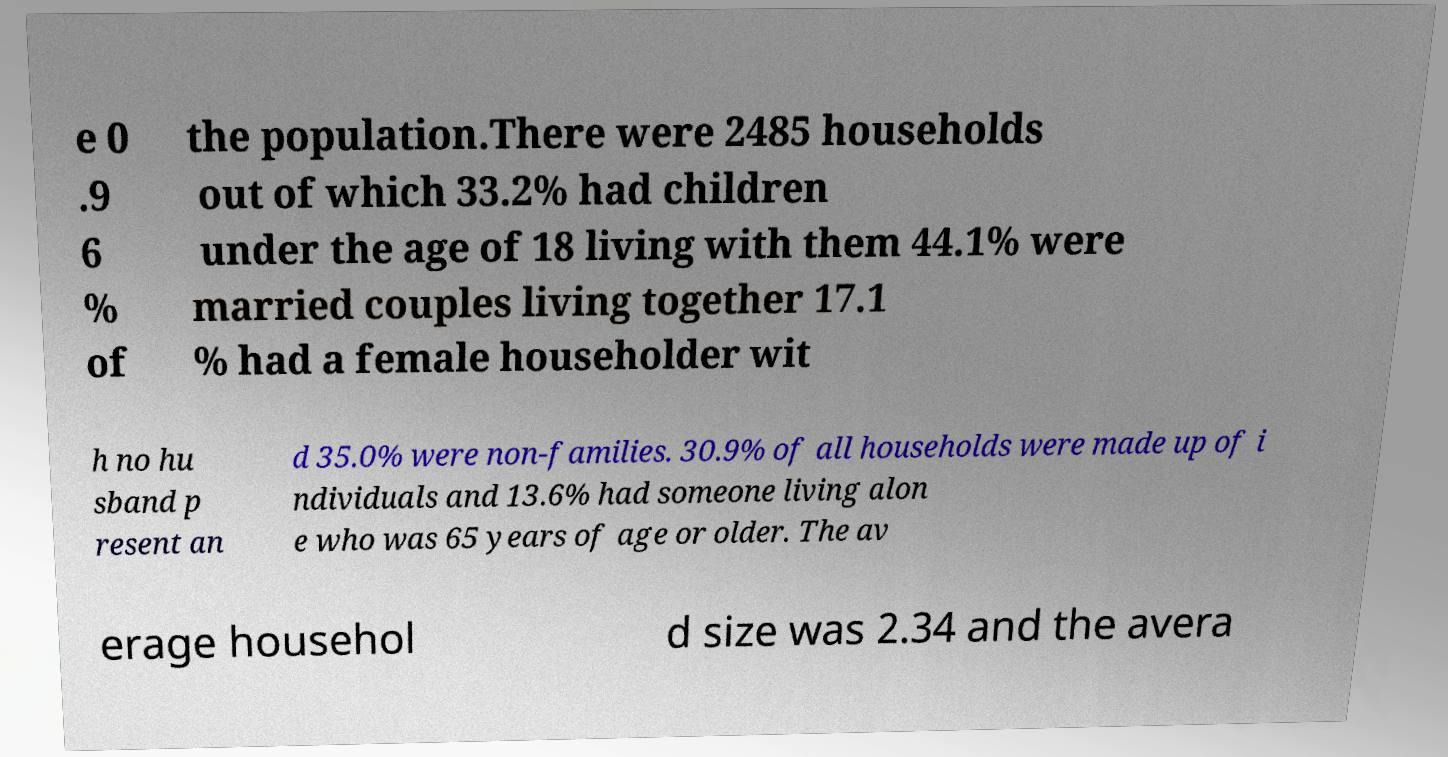What messages or text are displayed in this image? I need them in a readable, typed format. e 0 .9 6 % of the population.There were 2485 households out of which 33.2% had children under the age of 18 living with them 44.1% were married couples living together 17.1 % had a female householder wit h no hu sband p resent an d 35.0% were non-families. 30.9% of all households were made up of i ndividuals and 13.6% had someone living alon e who was 65 years of age or older. The av erage househol d size was 2.34 and the avera 